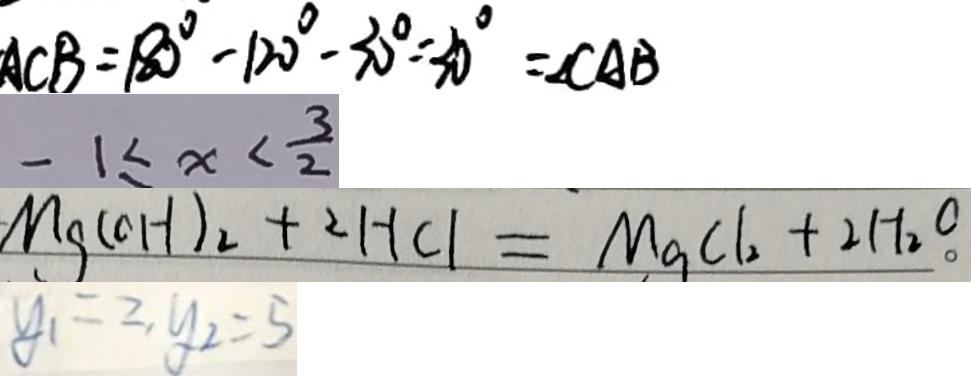Convert formula to latex. <formula><loc_0><loc_0><loc_500><loc_500>A C B = 1 8 0 ^ { \circ } - 1 2 0 ^ { \circ } - 3 0 ^ { \circ } = 3 0 ^ { \circ } = \angle C A B 
 - 1 \leq x < \frac { 3 } { 2 } 
 M g ( O H ) _ { 2 } + 2 H C l = M g C l _ { 2 } + 2 H _ { 2 } O 
 y _ { 1 } = 2 , y _ { 2 } = 5</formula> 